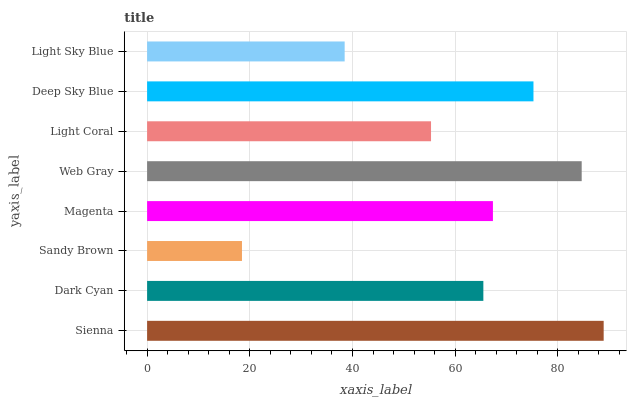Is Sandy Brown the minimum?
Answer yes or no. Yes. Is Sienna the maximum?
Answer yes or no. Yes. Is Dark Cyan the minimum?
Answer yes or no. No. Is Dark Cyan the maximum?
Answer yes or no. No. Is Sienna greater than Dark Cyan?
Answer yes or no. Yes. Is Dark Cyan less than Sienna?
Answer yes or no. Yes. Is Dark Cyan greater than Sienna?
Answer yes or no. No. Is Sienna less than Dark Cyan?
Answer yes or no. No. Is Magenta the high median?
Answer yes or no. Yes. Is Dark Cyan the low median?
Answer yes or no. Yes. Is Dark Cyan the high median?
Answer yes or no. No. Is Deep Sky Blue the low median?
Answer yes or no. No. 